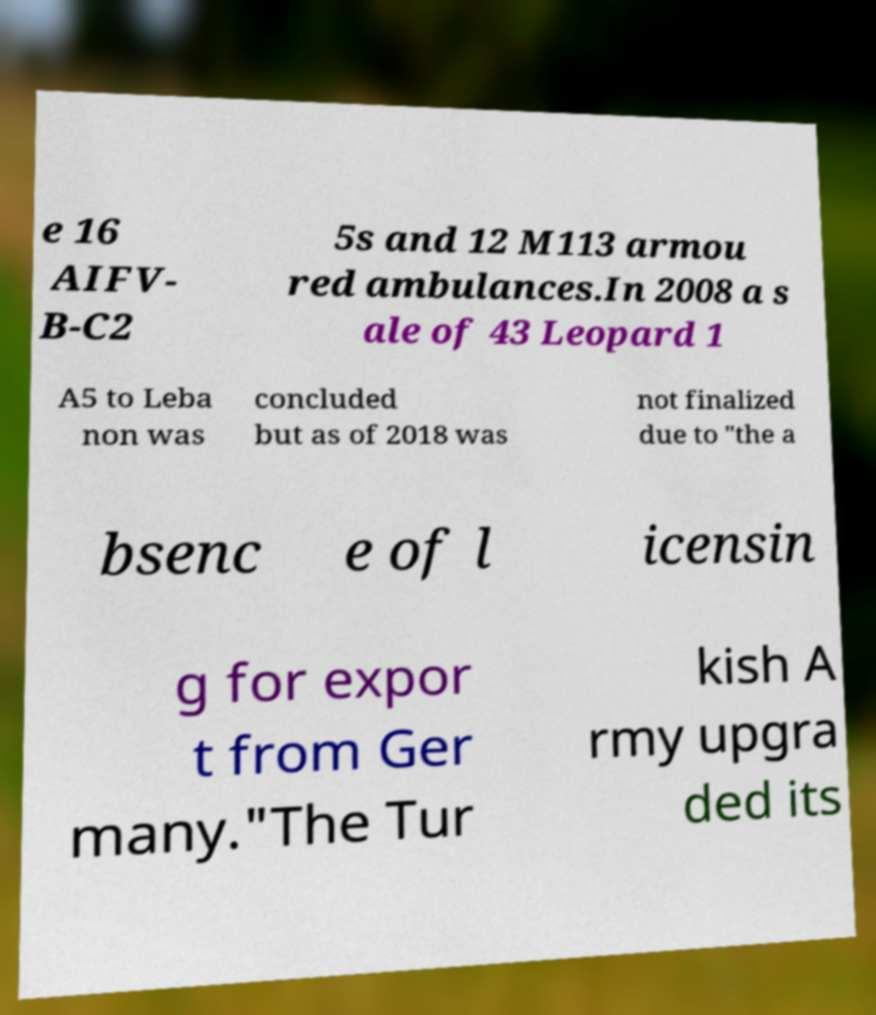Can you accurately transcribe the text from the provided image for me? e 16 AIFV- B-C2 5s and 12 M113 armou red ambulances.In 2008 a s ale of 43 Leopard 1 A5 to Leba non was concluded but as of 2018 was not finalized due to "the a bsenc e of l icensin g for expor t from Ger many."The Tur kish A rmy upgra ded its 